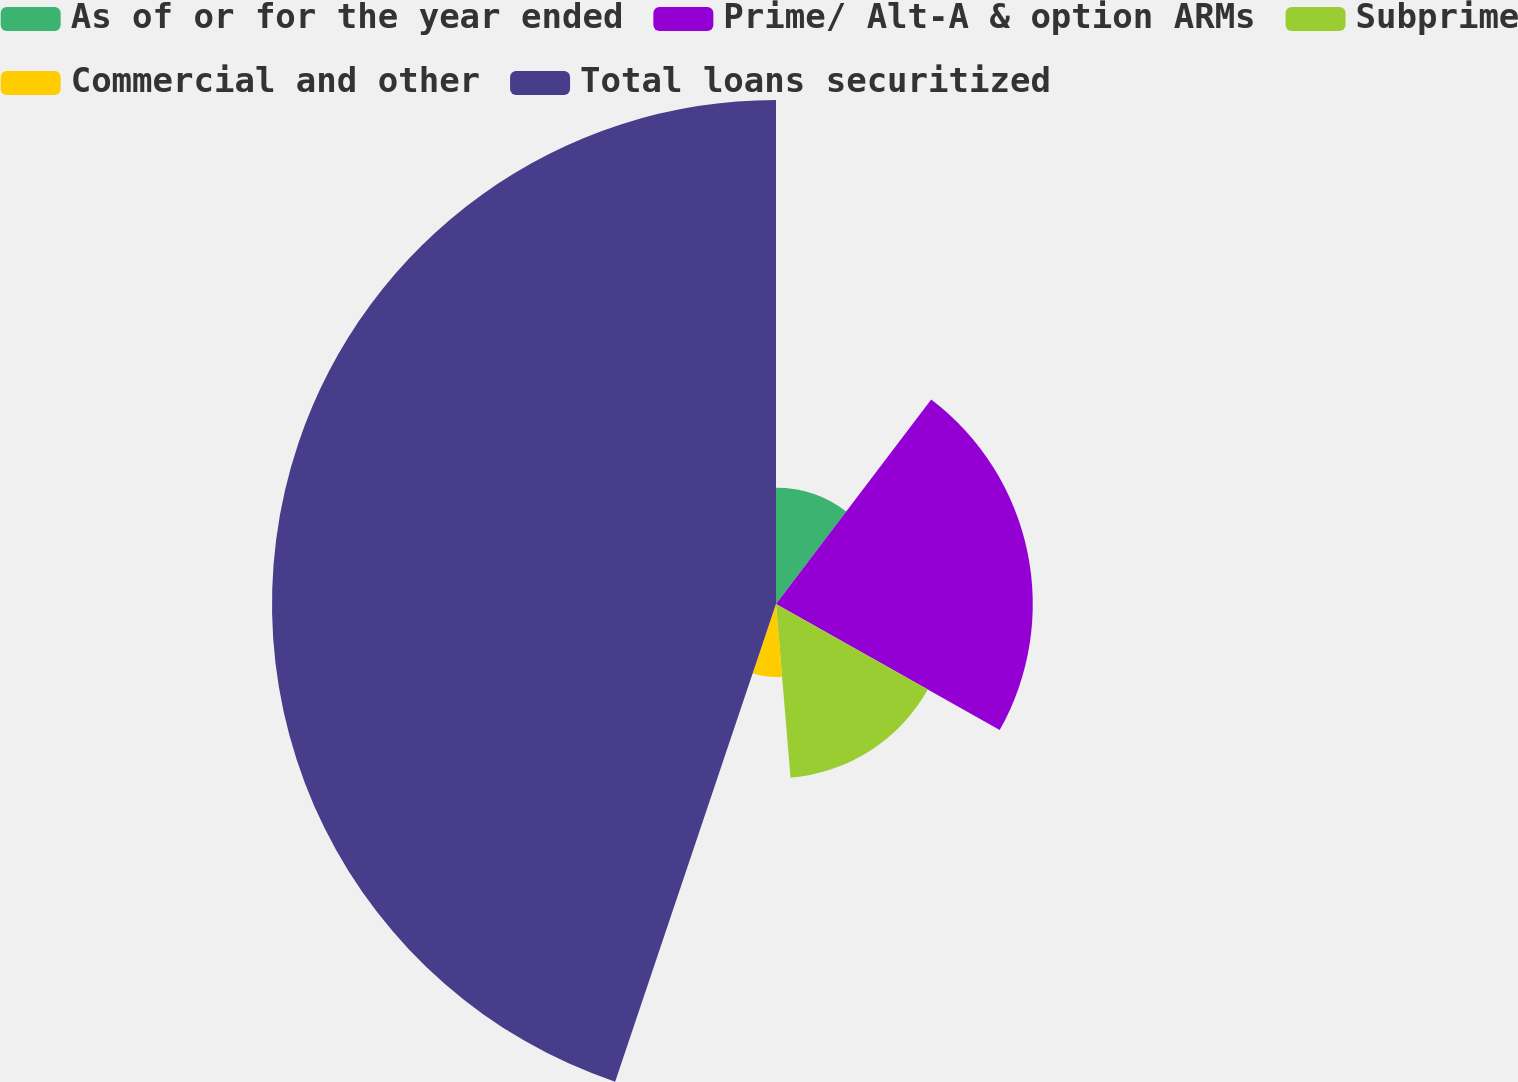Convert chart. <chart><loc_0><loc_0><loc_500><loc_500><pie_chart><fcel>As of or for the year ended<fcel>Prime/ Alt-A & option ARMs<fcel>Subprime<fcel>Commercial and other<fcel>Total loans securitized<nl><fcel>10.33%<fcel>22.84%<fcel>15.5%<fcel>6.5%<fcel>44.83%<nl></chart> 